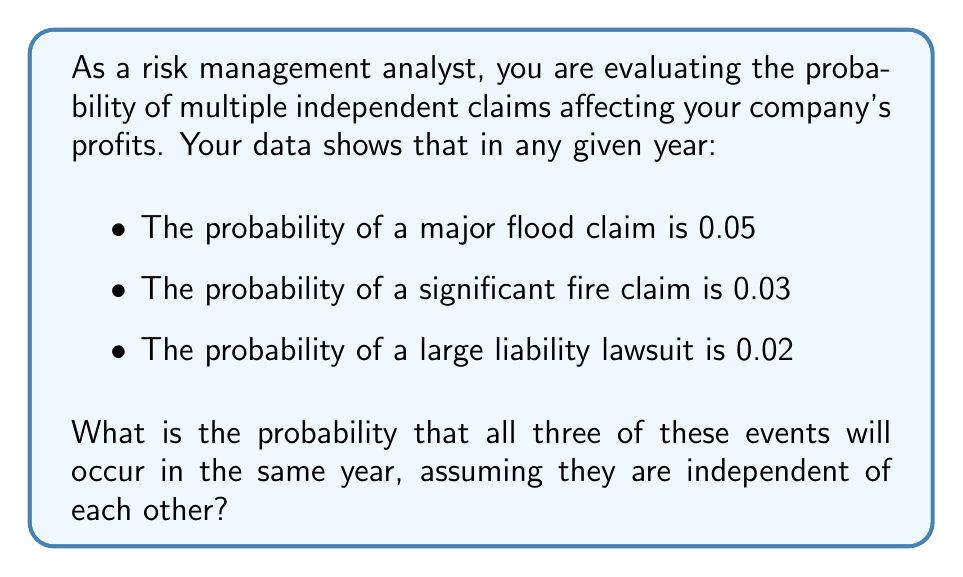What is the answer to this math problem? To solve this problem, we need to apply the multiplication rule for independent events. When events are independent, the probability of all of them occurring simultaneously is the product of their individual probabilities.

Let's define our events:
$A$ = major flood claim
$B$ = significant fire claim
$C$ = large liability lawsuit

Given:
$P(A) = 0.05$
$P(B) = 0.03$
$P(C) = 0.02$

We want to find $P(A \text{ and } B \text{ and } C)$

For independent events:

$$P(A \text{ and } B \text{ and } C) = P(A) \times P(B) \times P(C)$$

Substituting the given probabilities:

$$P(A \text{ and } B \text{ and } C) = 0.05 \times 0.03 \times 0.02$$

Calculating:

$$P(A \text{ and } B \text{ and } C) = 0.00003$$

This can also be expressed as $3 \times 10^{-5}$ or 0.003%.
Answer: The probability that all three events (major flood claim, significant fire claim, and large liability lawsuit) will occur in the same year is $0.00003$ or $3 \times 10^{-5}$ or $0.003\%$. 